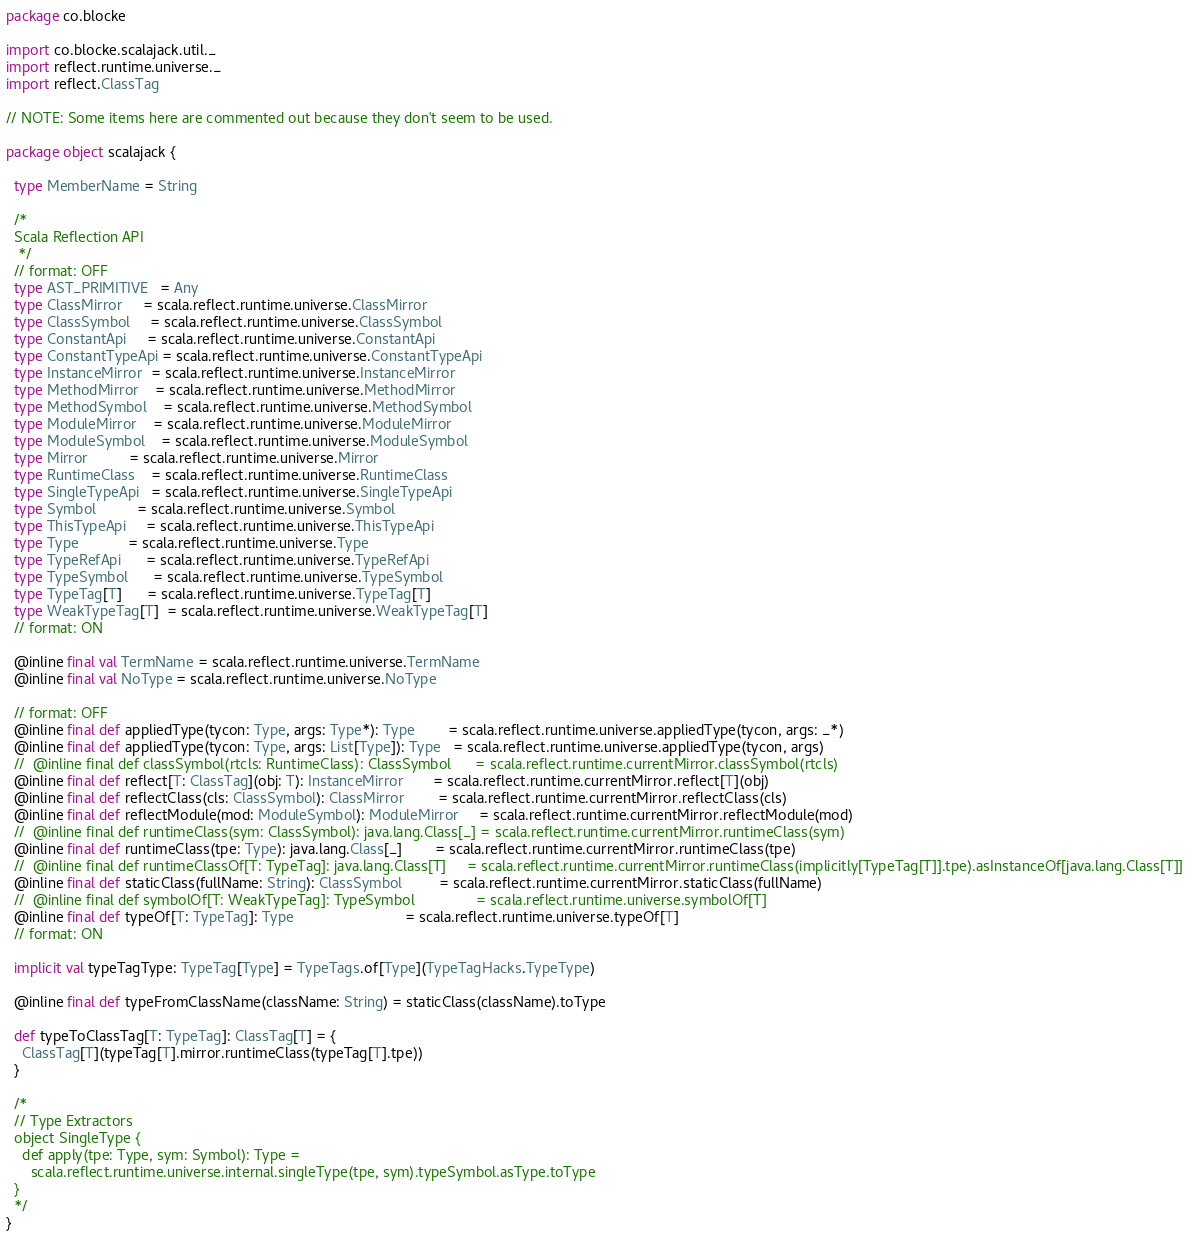<code> <loc_0><loc_0><loc_500><loc_500><_Scala_>package co.blocke

import co.blocke.scalajack.util._
import reflect.runtime.universe._
import reflect.ClassTag

// NOTE: Some items here are commented out because they don't seem to be used.

package object scalajack {

  type MemberName = String

  /*
  Scala Reflection API
   */
  // format: OFF
  type AST_PRIMITIVE   = Any
  type ClassMirror     = scala.reflect.runtime.universe.ClassMirror
  type ClassSymbol     = scala.reflect.runtime.universe.ClassSymbol
  type ConstantApi     = scala.reflect.runtime.universe.ConstantApi
  type ConstantTypeApi = scala.reflect.runtime.universe.ConstantTypeApi
  type InstanceMirror  = scala.reflect.runtime.universe.InstanceMirror
  type MethodMirror    = scala.reflect.runtime.universe.MethodMirror
  type MethodSymbol    = scala.reflect.runtime.universe.MethodSymbol
  type ModuleMirror    = scala.reflect.runtime.universe.ModuleMirror
  type ModuleSymbol    = scala.reflect.runtime.universe.ModuleSymbol
  type Mirror          = scala.reflect.runtime.universe.Mirror
  type RuntimeClass    = scala.reflect.runtime.universe.RuntimeClass
  type SingleTypeApi   = scala.reflect.runtime.universe.SingleTypeApi
  type Symbol          = scala.reflect.runtime.universe.Symbol
  type ThisTypeApi     = scala.reflect.runtime.universe.ThisTypeApi
  type Type            = scala.reflect.runtime.universe.Type
  type TypeRefApi      = scala.reflect.runtime.universe.TypeRefApi
  type TypeSymbol      = scala.reflect.runtime.universe.TypeSymbol
  type TypeTag[T]      = scala.reflect.runtime.universe.TypeTag[T]
  type WeakTypeTag[T]  = scala.reflect.runtime.universe.WeakTypeTag[T]
  // format: ON

  @inline final val TermName = scala.reflect.runtime.universe.TermName
  @inline final val NoType = scala.reflect.runtime.universe.NoType

  // format: OFF
  @inline final def appliedType(tycon: Type, args: Type*): Type        = scala.reflect.runtime.universe.appliedType(tycon, args: _*)
  @inline final def appliedType(tycon: Type, args: List[Type]): Type   = scala.reflect.runtime.universe.appliedType(tycon, args)
  //  @inline final def classSymbol(rtcls: RuntimeClass): ClassSymbol      = scala.reflect.runtime.currentMirror.classSymbol(rtcls)
  @inline final def reflect[T: ClassTag](obj: T): InstanceMirror       = scala.reflect.runtime.currentMirror.reflect[T](obj)
  @inline final def reflectClass(cls: ClassSymbol): ClassMirror        = scala.reflect.runtime.currentMirror.reflectClass(cls)
  @inline final def reflectModule(mod: ModuleSymbol): ModuleMirror     = scala.reflect.runtime.currentMirror.reflectModule(mod)
  //  @inline final def runtimeClass(sym: ClassSymbol): java.lang.Class[_] = scala.reflect.runtime.currentMirror.runtimeClass(sym)
  @inline final def runtimeClass(tpe: Type): java.lang.Class[_]        = scala.reflect.runtime.currentMirror.runtimeClass(tpe)
  //  @inline final def runtimeClassOf[T: TypeTag]: java.lang.Class[T]     = scala.reflect.runtime.currentMirror.runtimeClass(implicitly[TypeTag[T]].tpe).asInstanceOf[java.lang.Class[T]]
  @inline final def staticClass(fullName: String): ClassSymbol         = scala.reflect.runtime.currentMirror.staticClass(fullName)
  //  @inline final def symbolOf[T: WeakTypeTag]: TypeSymbol               = scala.reflect.runtime.universe.symbolOf[T]
  @inline final def typeOf[T: TypeTag]: Type                           = scala.reflect.runtime.universe.typeOf[T]
  // format: ON

  implicit val typeTagType: TypeTag[Type] = TypeTags.of[Type](TypeTagHacks.TypeType)

  @inline final def typeFromClassName(className: String) = staticClass(className).toType

  def typeToClassTag[T: TypeTag]: ClassTag[T] = {
    ClassTag[T](typeTag[T].mirror.runtimeClass(typeTag[T].tpe))
  }

  /*
  // Type Extractors
  object SingleType {
    def apply(tpe: Type, sym: Symbol): Type =
      scala.reflect.runtime.universe.internal.singleType(tpe, sym).typeSymbol.asType.toType
  }
  */
}

</code> 